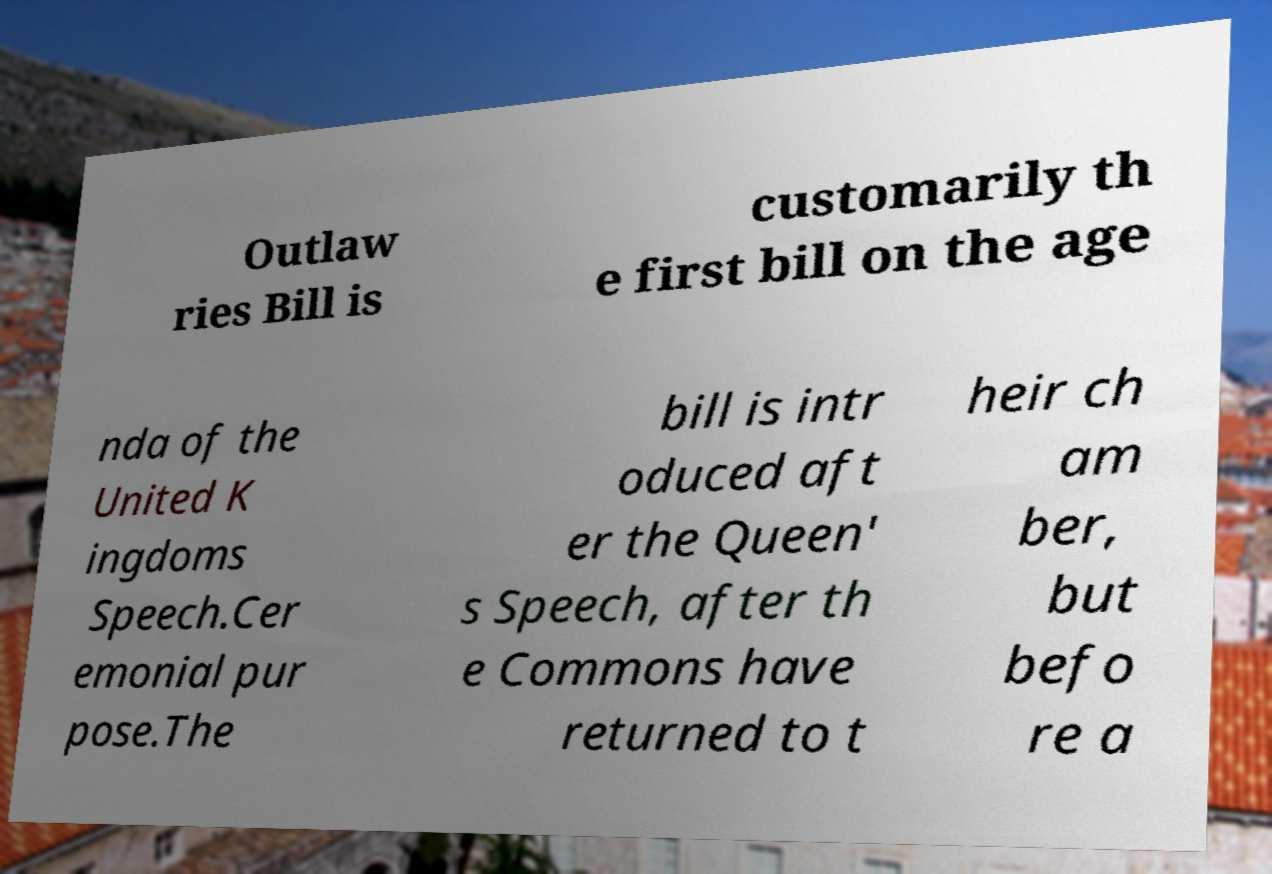Can you read and provide the text displayed in the image?This photo seems to have some interesting text. Can you extract and type it out for me? Outlaw ries Bill is customarily th e first bill on the age nda of the United K ingdoms Speech.Cer emonial pur pose.The bill is intr oduced aft er the Queen' s Speech, after th e Commons have returned to t heir ch am ber, but befo re a 